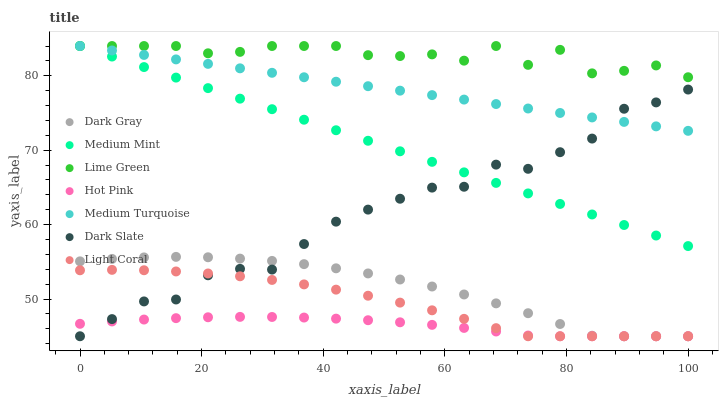Does Hot Pink have the minimum area under the curve?
Answer yes or no. Yes. Does Lime Green have the maximum area under the curve?
Answer yes or no. Yes. Does Light Coral have the minimum area under the curve?
Answer yes or no. No. Does Light Coral have the maximum area under the curve?
Answer yes or no. No. Is Medium Turquoise the smoothest?
Answer yes or no. Yes. Is Dark Slate the roughest?
Answer yes or no. Yes. Is Light Coral the smoothest?
Answer yes or no. No. Is Light Coral the roughest?
Answer yes or no. No. Does Light Coral have the lowest value?
Answer yes or no. Yes. Does Medium Turquoise have the lowest value?
Answer yes or no. No. Does Lime Green have the highest value?
Answer yes or no. Yes. Does Light Coral have the highest value?
Answer yes or no. No. Is Light Coral less than Lime Green?
Answer yes or no. Yes. Is Medium Mint greater than Light Coral?
Answer yes or no. Yes. Does Medium Turquoise intersect Medium Mint?
Answer yes or no. Yes. Is Medium Turquoise less than Medium Mint?
Answer yes or no. No. Is Medium Turquoise greater than Medium Mint?
Answer yes or no. No. Does Light Coral intersect Lime Green?
Answer yes or no. No. 